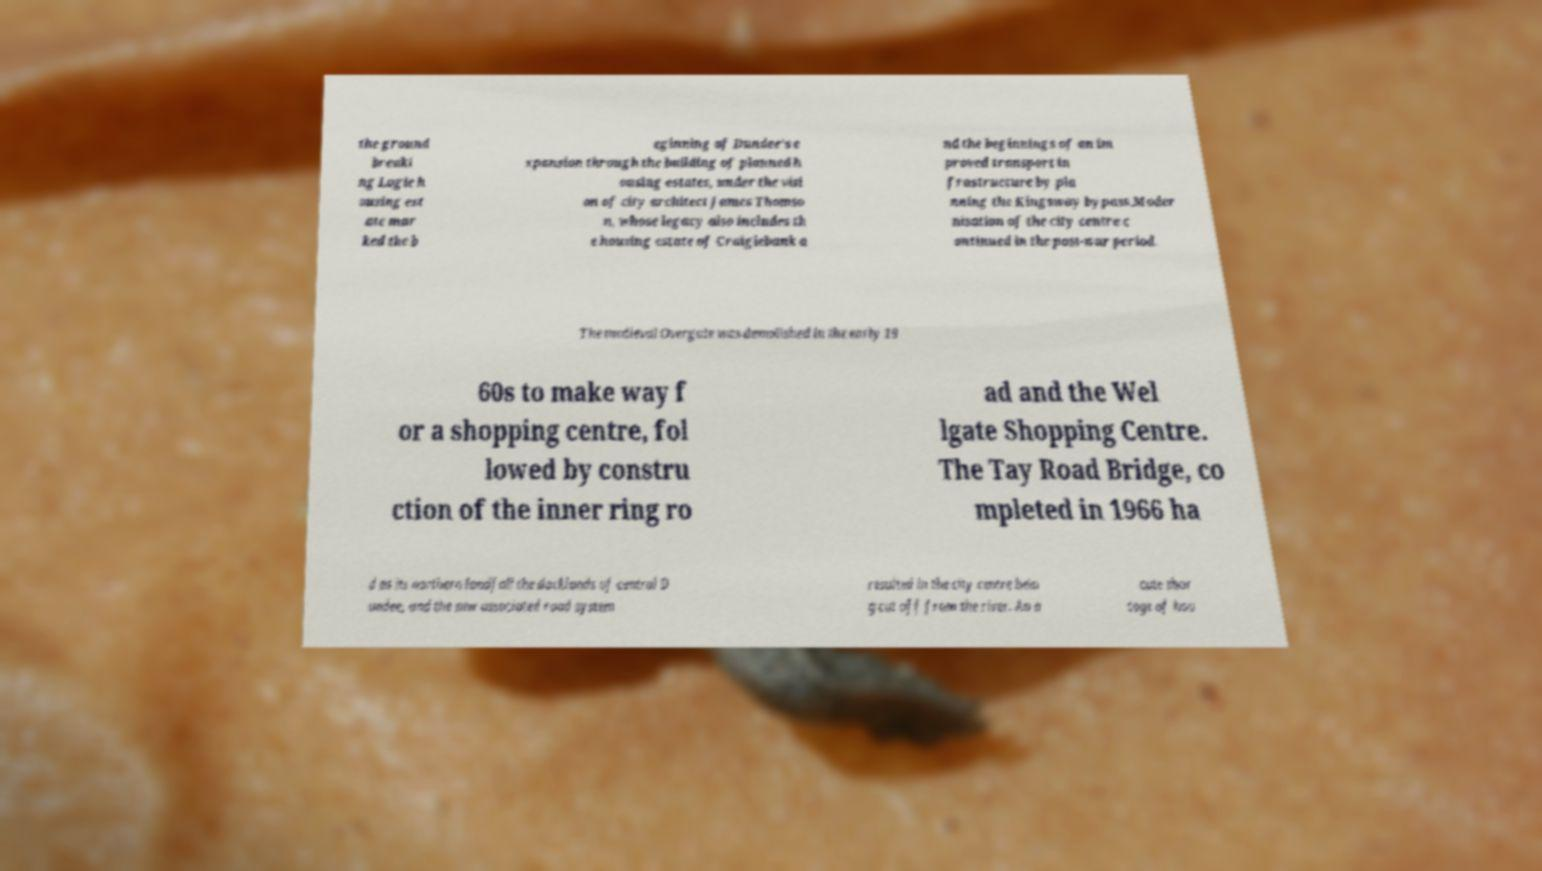There's text embedded in this image that I need extracted. Can you transcribe it verbatim? the ground breaki ng Logie h ousing est ate mar ked the b eginning of Dundee's e xpansion through the building of planned h ousing estates, under the visi on of city architect James Thomso n, whose legacy also includes th e housing estate of Craigiebank a nd the beginnings of an im proved transport in frastructure by pla nning the Kingsway bypass.Moder nisation of the city centre c ontinued in the post-war period. The medieval Overgate was demolished in the early 19 60s to make way f or a shopping centre, fol lowed by constru ction of the inner ring ro ad and the Wel lgate Shopping Centre. The Tay Road Bridge, co mpleted in 1966 ha d as its northern landfall the docklands of central D undee, and the new associated road system resulted in the city centre bein g cut off from the river. An a cute shor tage of hou 